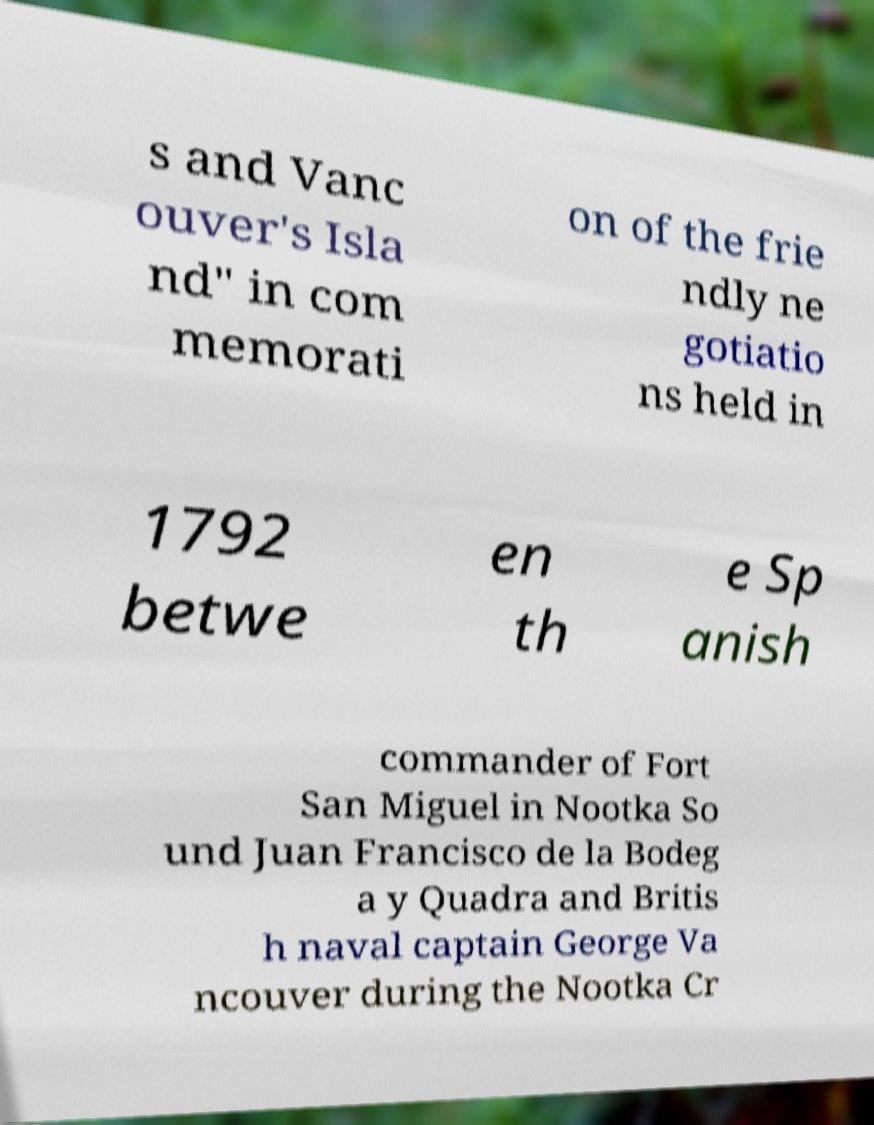There's text embedded in this image that I need extracted. Can you transcribe it verbatim? s and Vanc ouver's Isla nd" in com memorati on of the frie ndly ne gotiatio ns held in 1792 betwe en th e Sp anish commander of Fort San Miguel in Nootka So und Juan Francisco de la Bodeg a y Quadra and Britis h naval captain George Va ncouver during the Nootka Cr 